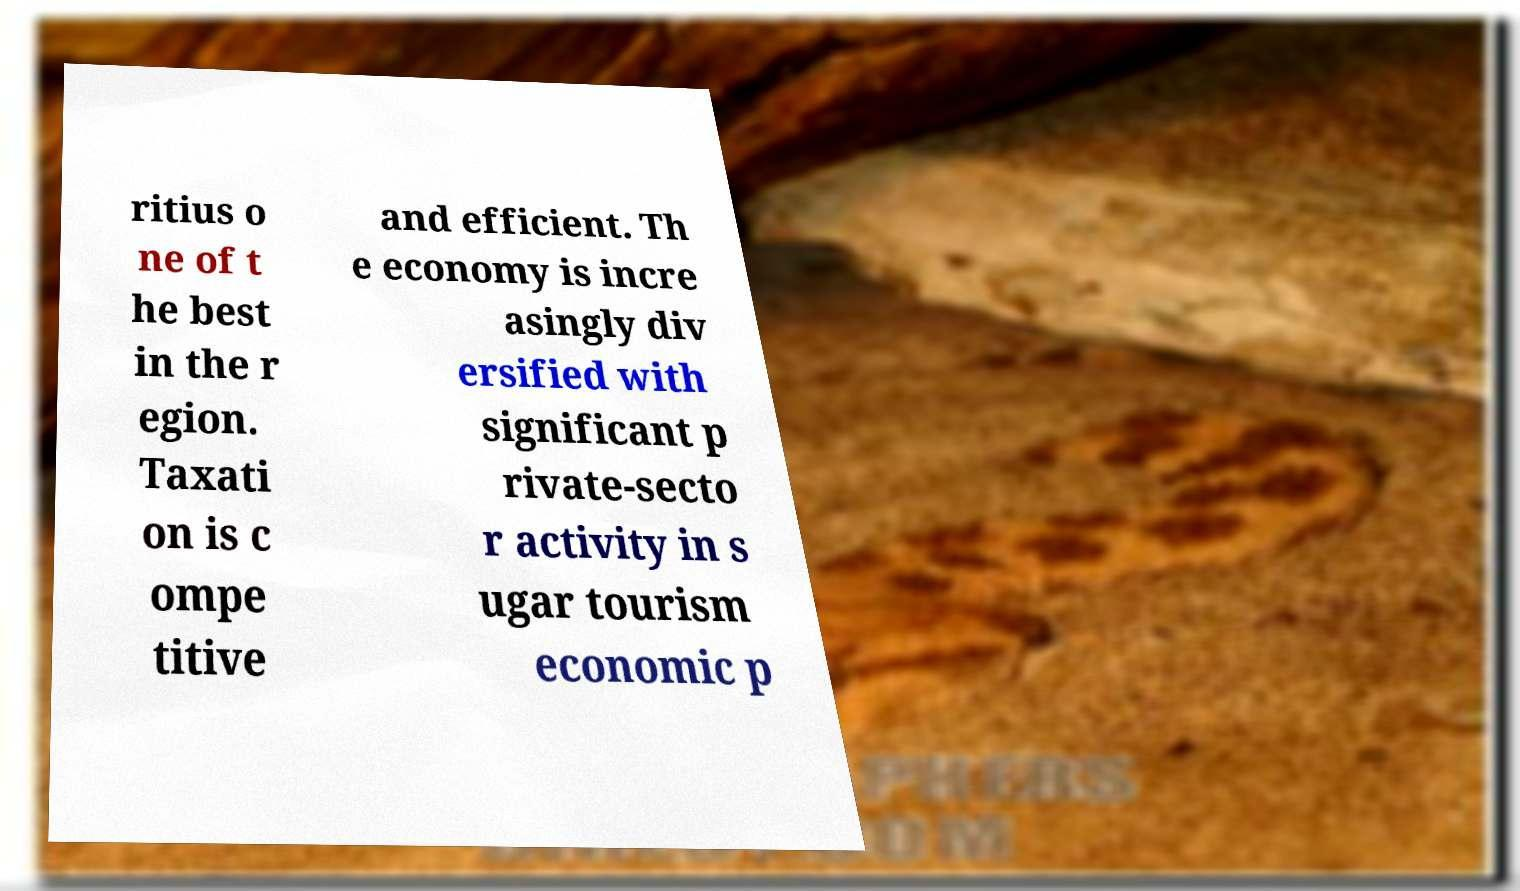Can you accurately transcribe the text from the provided image for me? ritius o ne of t he best in the r egion. Taxati on is c ompe titive and efficient. Th e economy is incre asingly div ersified with significant p rivate-secto r activity in s ugar tourism economic p 